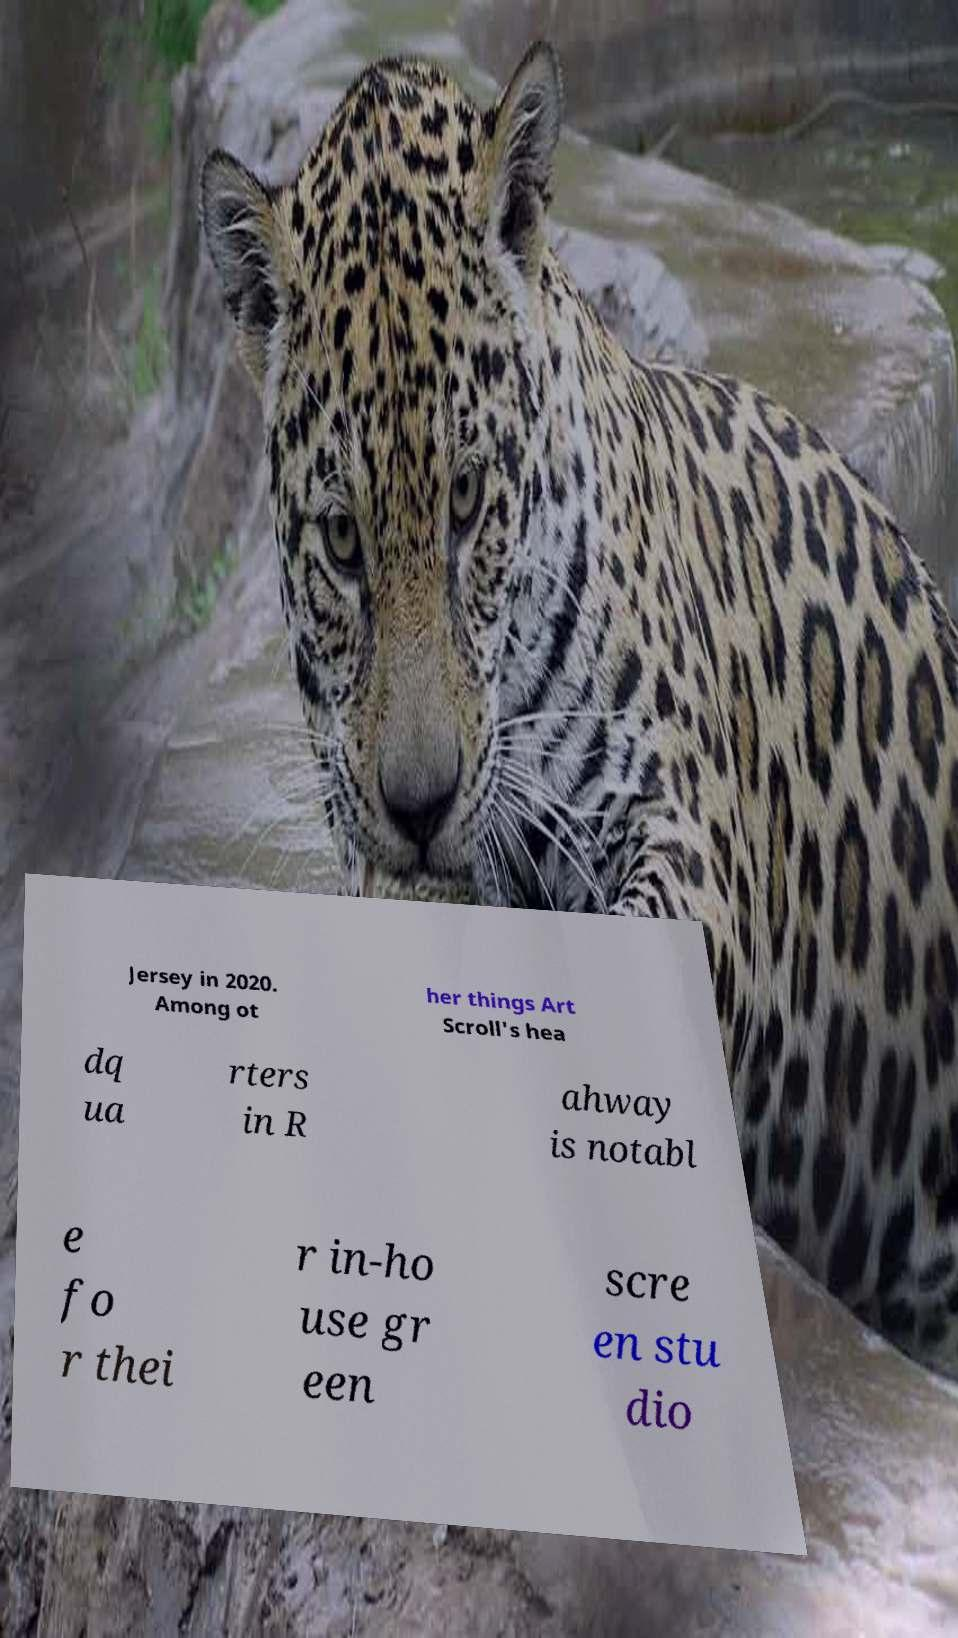There's text embedded in this image that I need extracted. Can you transcribe it verbatim? Jersey in 2020. Among ot her things Art Scroll's hea dq ua rters in R ahway is notabl e fo r thei r in-ho use gr een scre en stu dio 